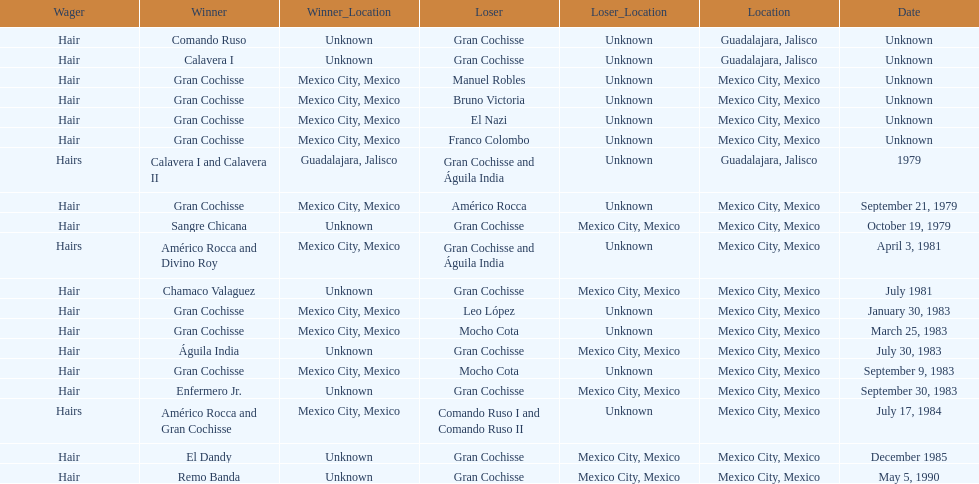How many games more than chamaco valaguez did sangre chicana win? 0. 